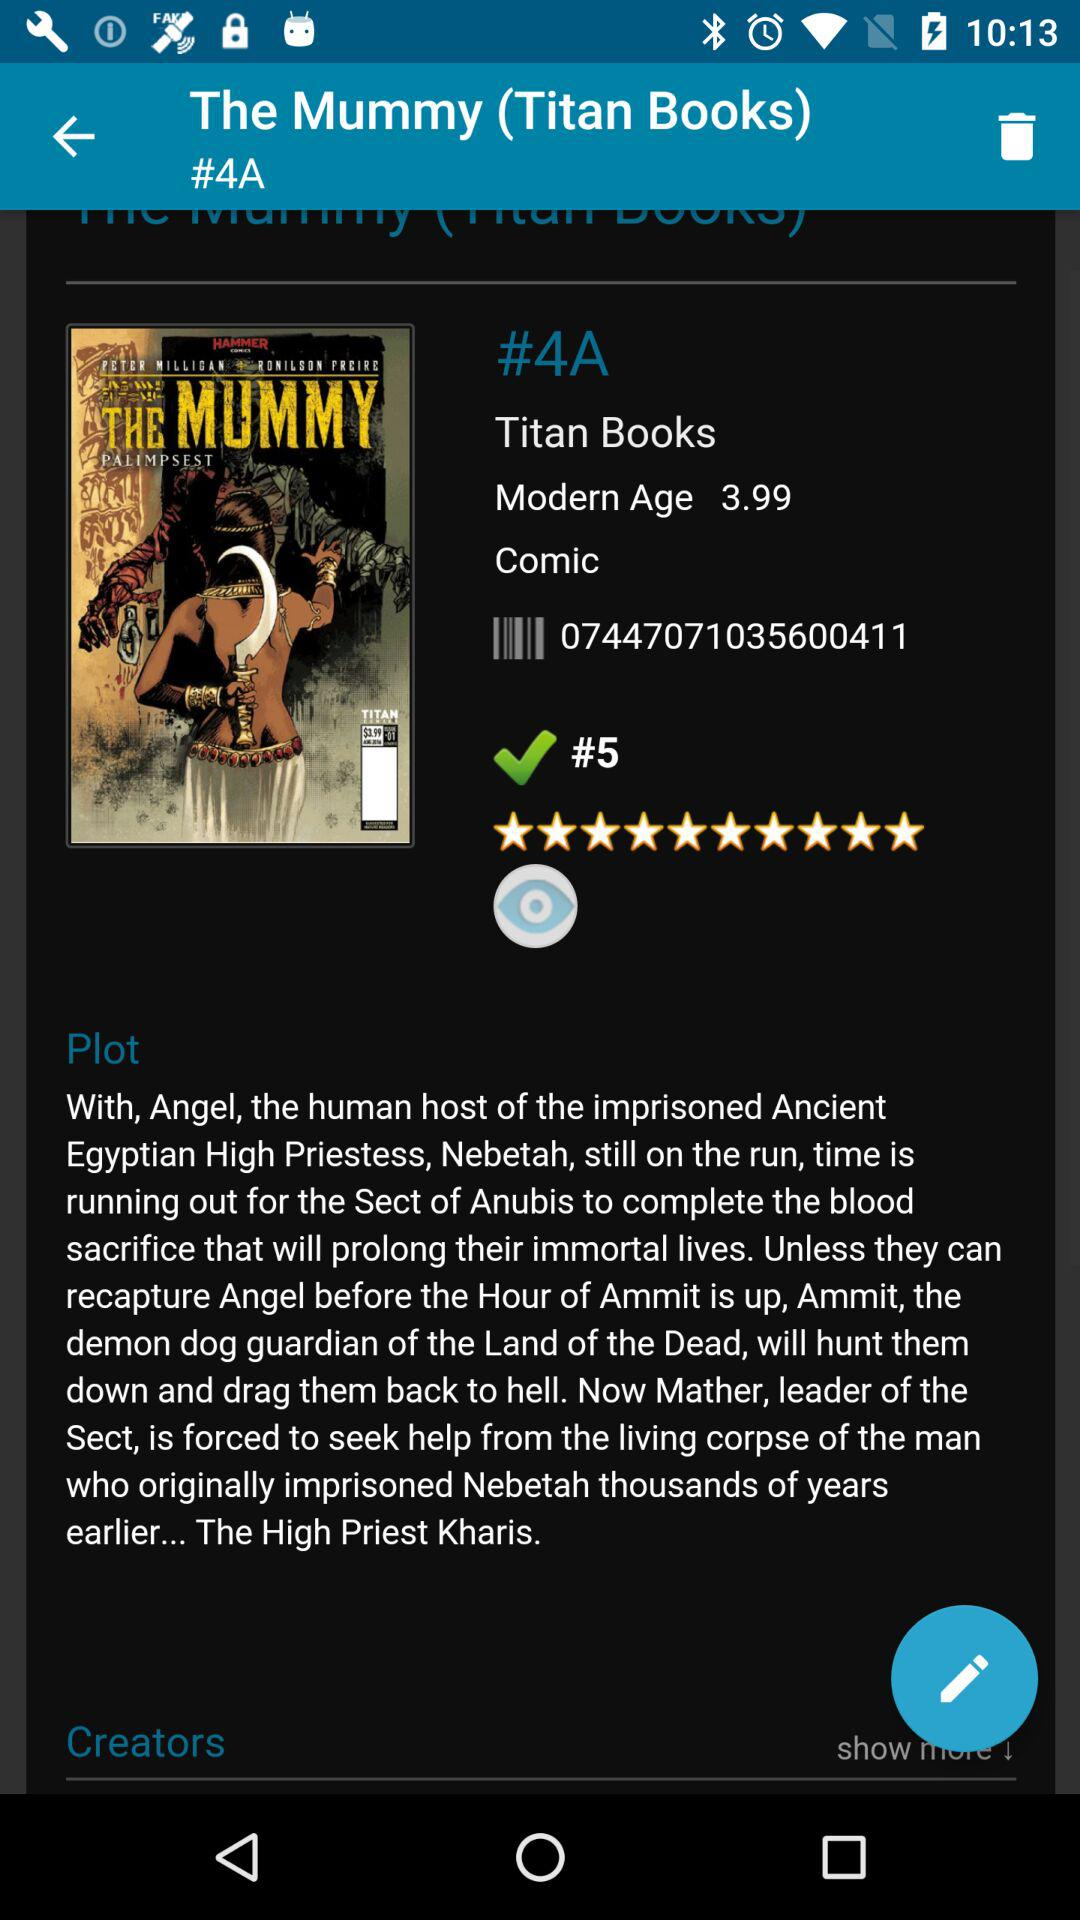What is the modern age? The modern age is 3.99. 